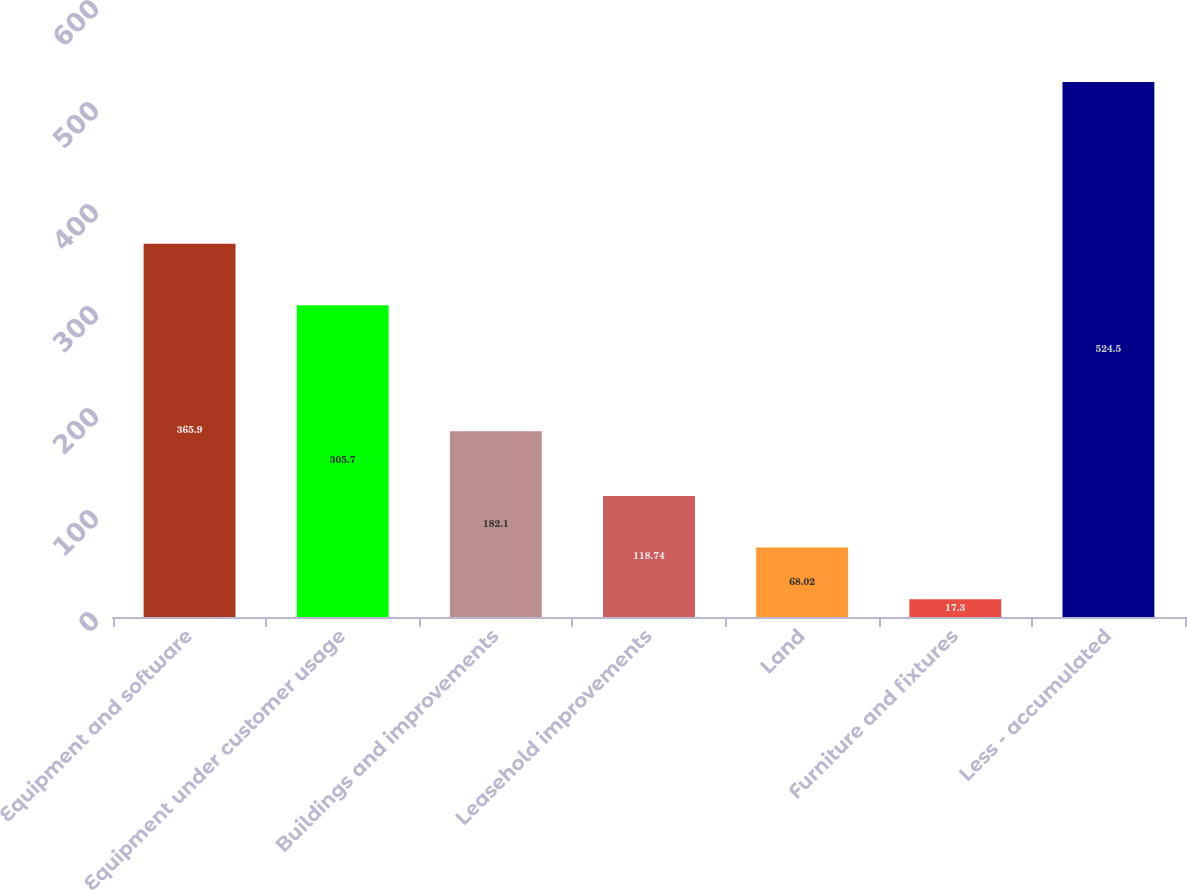<chart> <loc_0><loc_0><loc_500><loc_500><bar_chart><fcel>Equipment and software<fcel>Equipment under customer usage<fcel>Buildings and improvements<fcel>Leasehold improvements<fcel>Land<fcel>Furniture and fixtures<fcel>Less - accumulated<nl><fcel>365.9<fcel>305.7<fcel>182.1<fcel>118.74<fcel>68.02<fcel>17.3<fcel>524.5<nl></chart> 